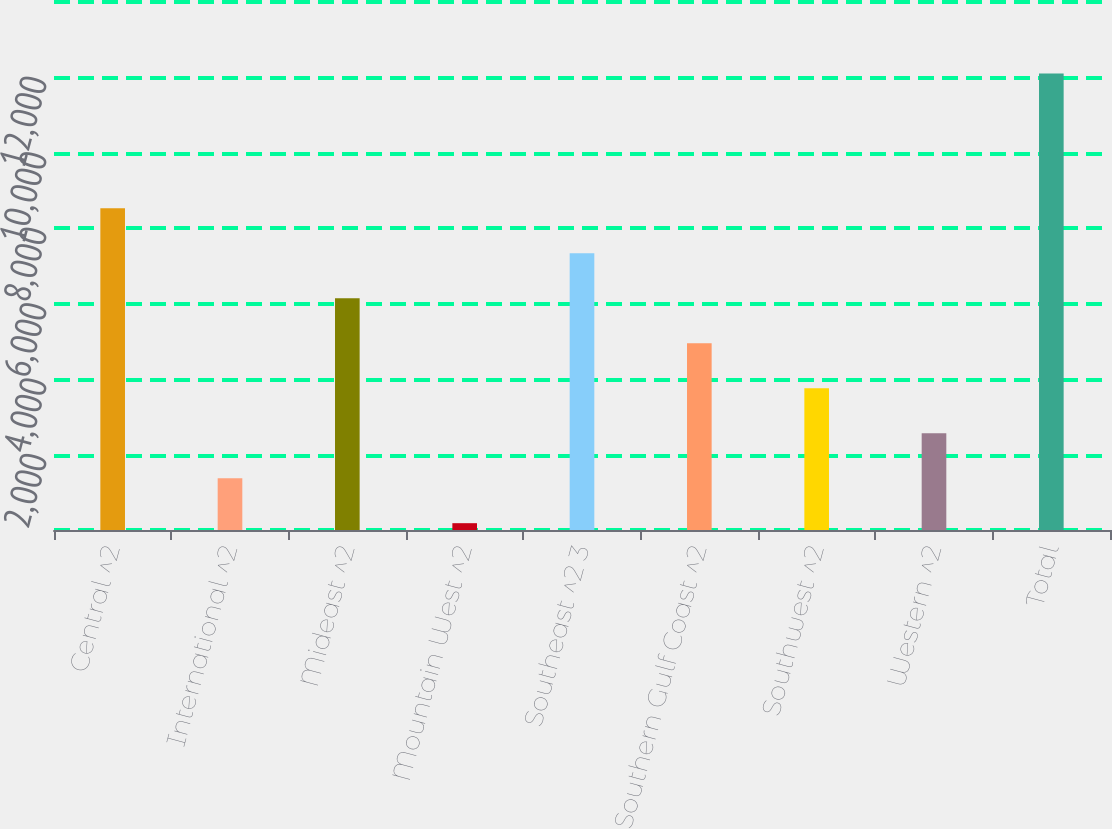Convert chart. <chart><loc_0><loc_0><loc_500><loc_500><bar_chart><fcel>Central ^2<fcel>International ^2<fcel>Mideast ^2<fcel>Mountain West ^2<fcel>Southeast ^2 3<fcel>Southern Gulf Coast ^2<fcel>Southwest ^2<fcel>Western ^2<fcel>Total<nl><fcel>8528.02<fcel>1373.26<fcel>6143.1<fcel>180.8<fcel>7335.56<fcel>4950.64<fcel>3758.18<fcel>2565.72<fcel>12105.4<nl></chart> 